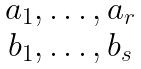Convert formula to latex. <formula><loc_0><loc_0><loc_500><loc_500>\begin{matrix} a _ { 1 } , \dots , a _ { r } \\ b _ { 1 } , \dots , b _ { s } \end{matrix}</formula> 